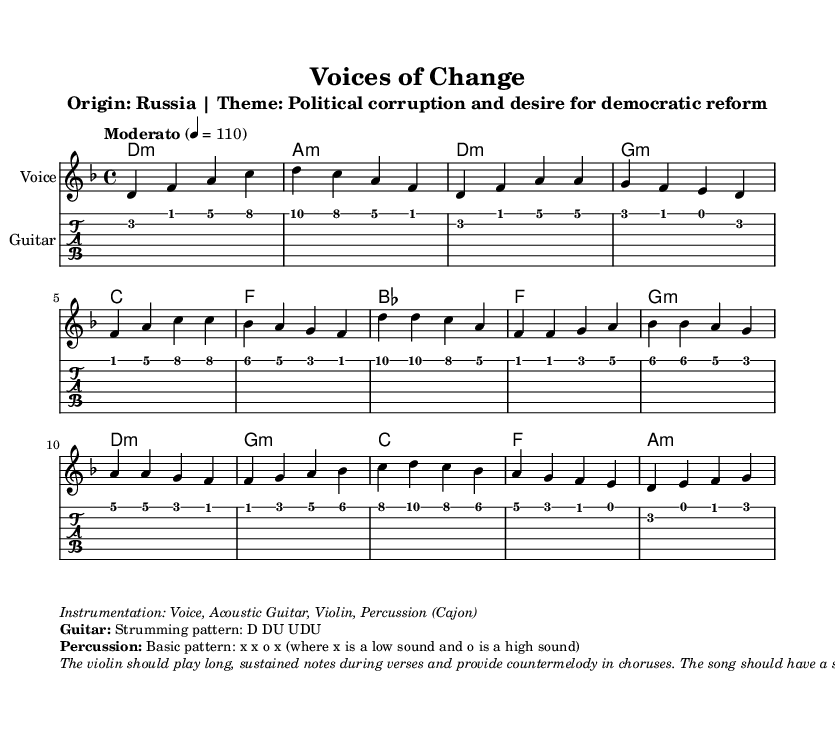What is the key signature of this music? The key signature indicates D minor, which includes one flat (B flat).
Answer: D minor What is the time signature of the piece? The time signature is written as 4/4, which means there are four beats in each measure and the quarter note gets one beat.
Answer: 4/4 What is the tempo marking for this music? The tempo marking is "Moderato," which suggests a moderate pace, generally around 108 to 120 beats per minute.
Answer: Moderato How many measures are in the chorus section? By analyzing the sheet music, the chorus includes four measures: two complete measures followed by two additional guiding phrases.
Answer: 4 What instrumentation is suggested for this piece? The instrumentation is detailed in the markup and includes voice, acoustic guitar, violin, and percussion (cajon).
Answer: Voice, Acoustic Guitar, Violin, Percussion What strumming pattern is indicated for the guitar? The strumming pattern written in the markup is "D DU UDU," showing how the chord should be played with varied strokes.
Answer: D DU UDU What mood does the music aim to convey according to the sheet music? The markup mentions a "somber yet determined feel," which reflects seriousness while inspiring hope for change.
Answer: Somber yet determined 